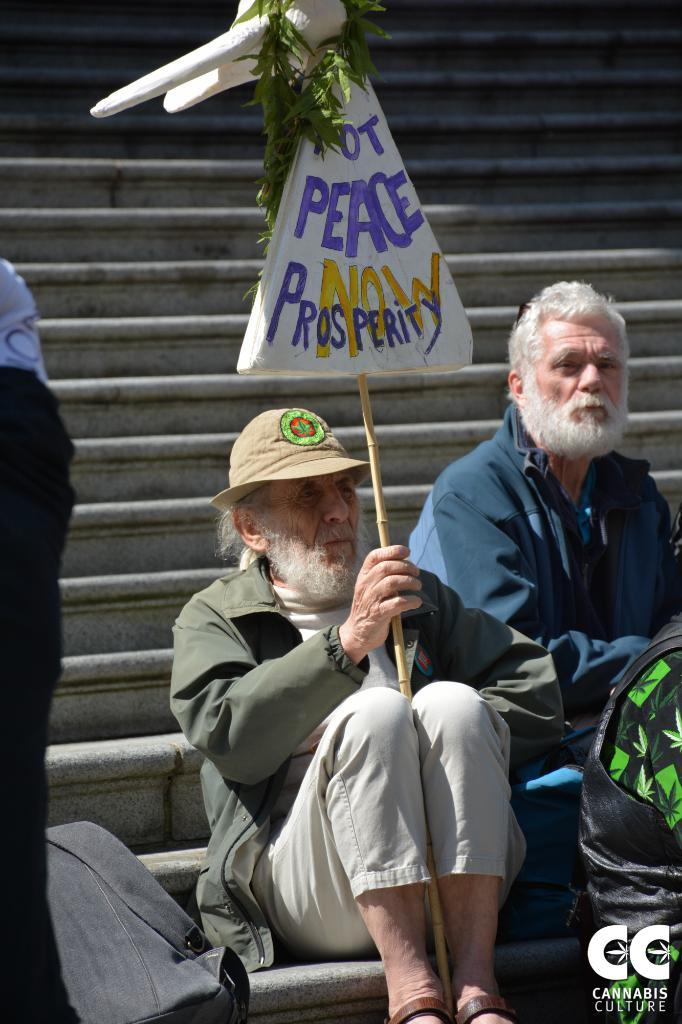What is the man in the image doing? The man is sitting on the stairs. What is the man holding in the image? The man is holding a board with a stick. What is attached to the board? There is a garland of leaves attached to the board. What else can be seen in the image? There is a bag visible in the image. Who else is present in the image? There is a person sitting beside the man with the board. How does the man plan to increase the number of snakes in the image? There are no snakes present in the image, and the man is not attempting to increase their number. 